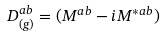Convert formula to latex. <formula><loc_0><loc_0><loc_500><loc_500>D _ { ( g ) } ^ { a b } = ( M ^ { a b } - i M ^ { * a b } )</formula> 